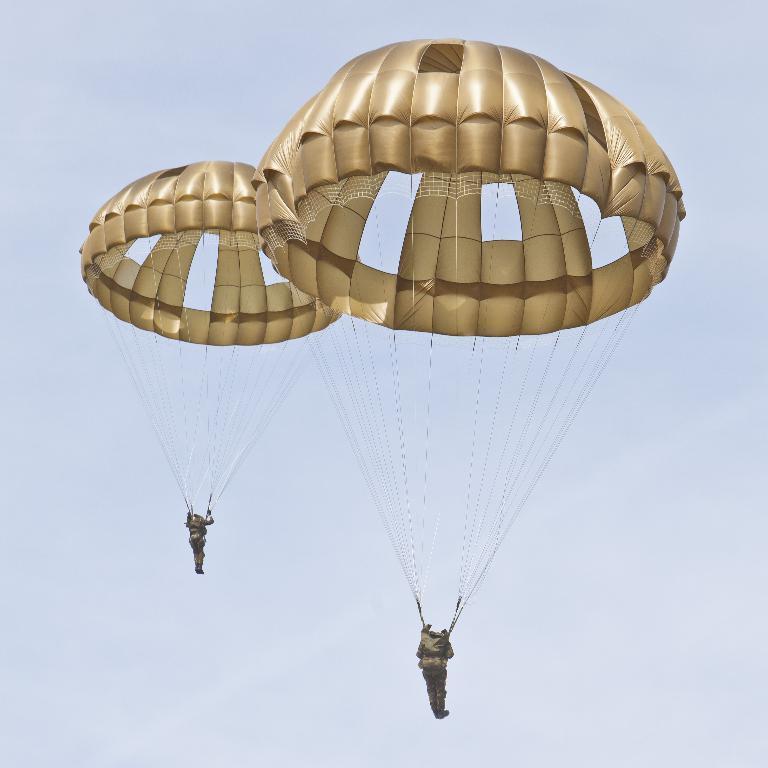Please provide a concise description of this image. The picture consists of two persons with parachute in the air. 